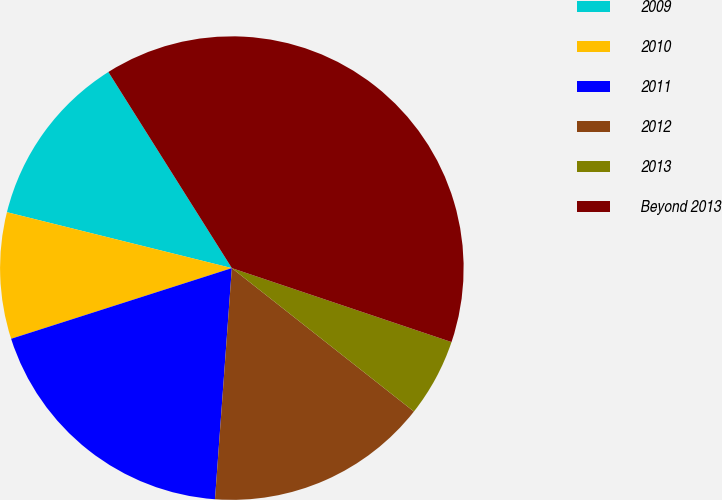Convert chart to OTSL. <chart><loc_0><loc_0><loc_500><loc_500><pie_chart><fcel>2009<fcel>2010<fcel>2011<fcel>2012<fcel>2013<fcel>Beyond 2013<nl><fcel>12.18%<fcel>8.81%<fcel>18.91%<fcel>15.54%<fcel>5.45%<fcel>39.11%<nl></chart> 